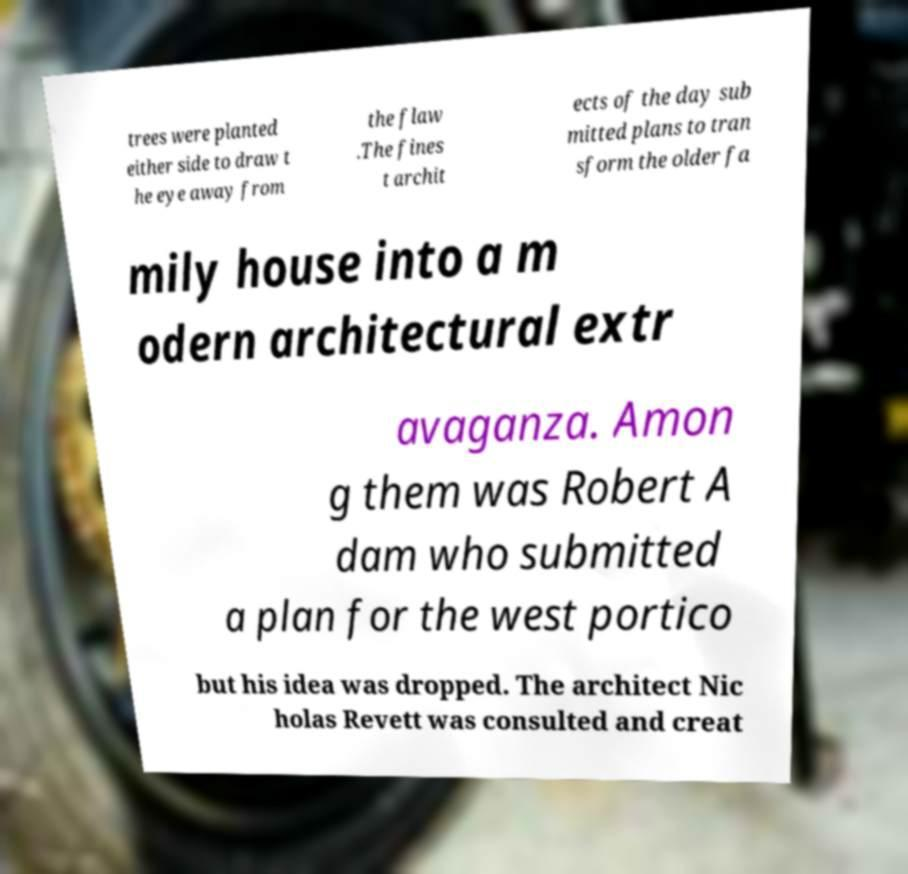Could you extract and type out the text from this image? trees were planted either side to draw t he eye away from the flaw .The fines t archit ects of the day sub mitted plans to tran sform the older fa mily house into a m odern architectural extr avaganza. Amon g them was Robert A dam who submitted a plan for the west portico but his idea was dropped. The architect Nic holas Revett was consulted and creat 